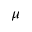Convert formula to latex. <formula><loc_0><loc_0><loc_500><loc_500>\mu</formula> 